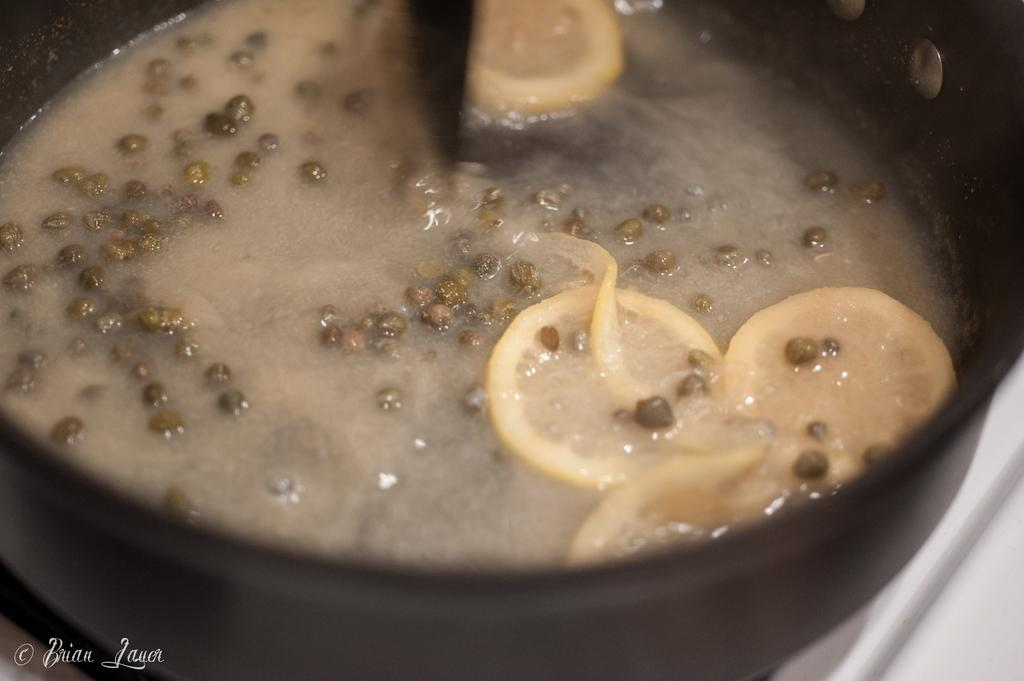What is in the bowl that is visible in the image? There is a bowl of soup in the image. What additional items can be seen in the image? There are lemon slices in the image. What type of plastic material is used to make the lemon slices in the image? The lemon slices in the image are not made of plastic; they are made of actual lemon fruit. 